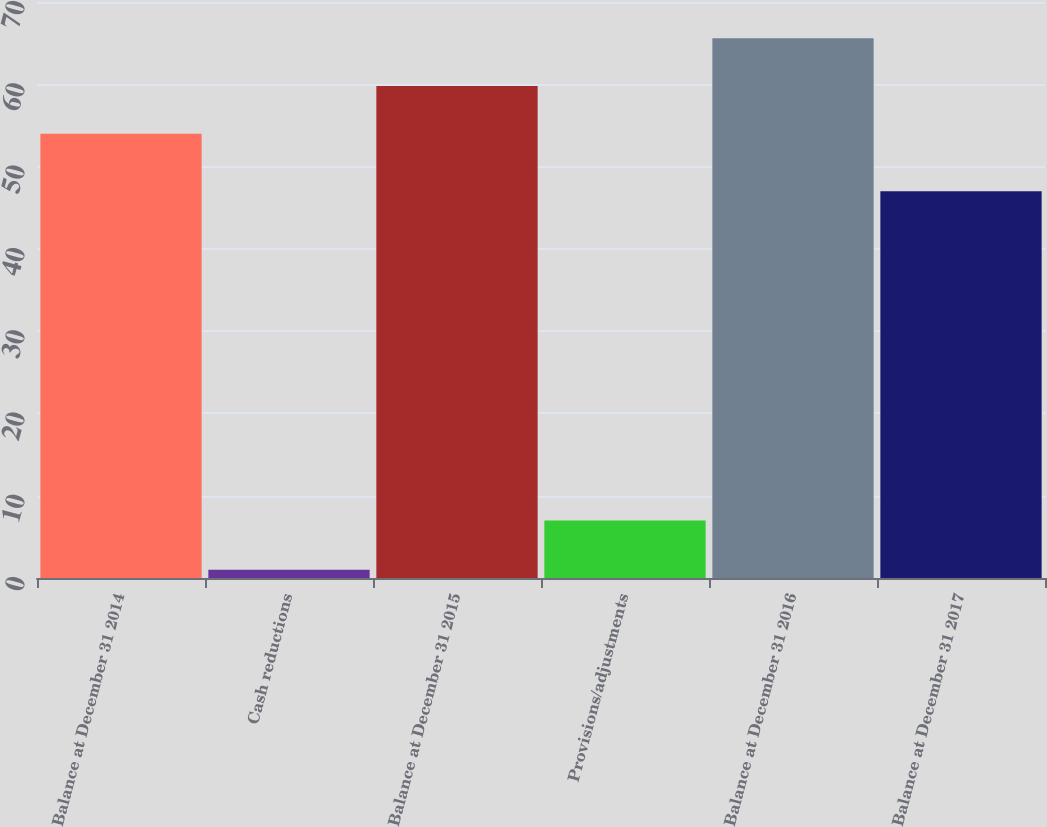Convert chart. <chart><loc_0><loc_0><loc_500><loc_500><bar_chart><fcel>Balance at December 31 2014<fcel>Cash reductions<fcel>Balance at December 31 2015<fcel>Provisions/adjustments<fcel>Balance at December 31 2016<fcel>Balance at December 31 2017<nl><fcel>54<fcel>1<fcel>59.8<fcel>7<fcel>65.6<fcel>47<nl></chart> 